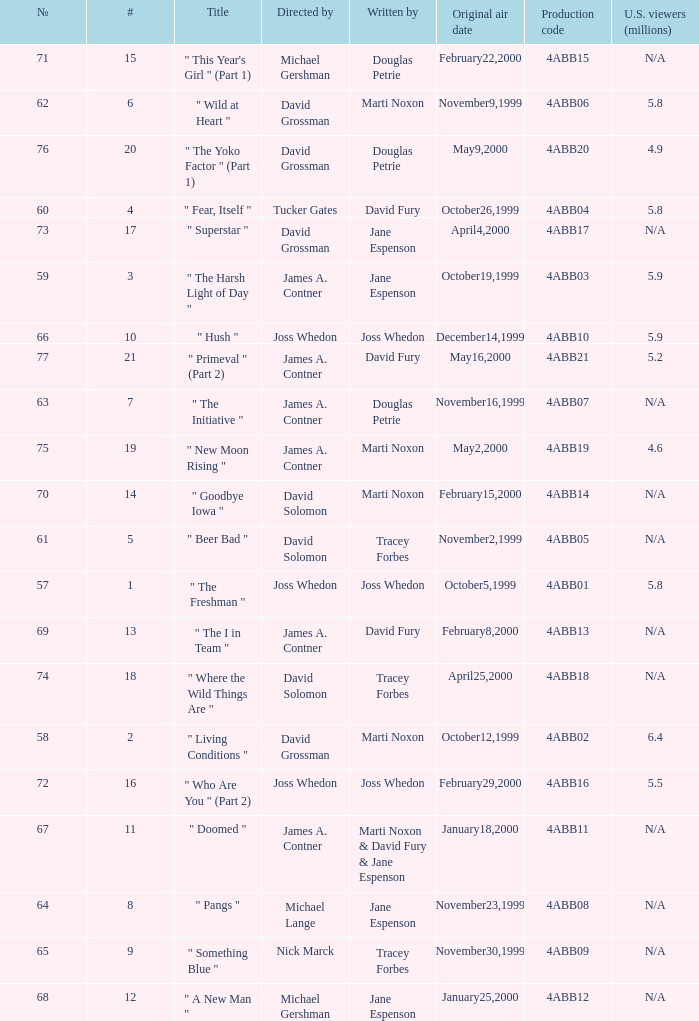What is the production code for the episode with 5.5 million u.s. viewers? 4ABB16. 